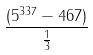<formula> <loc_0><loc_0><loc_500><loc_500>\frac { ( 5 ^ { 3 3 7 } - 4 6 7 ) } { \frac { 1 } { 3 } }</formula> 